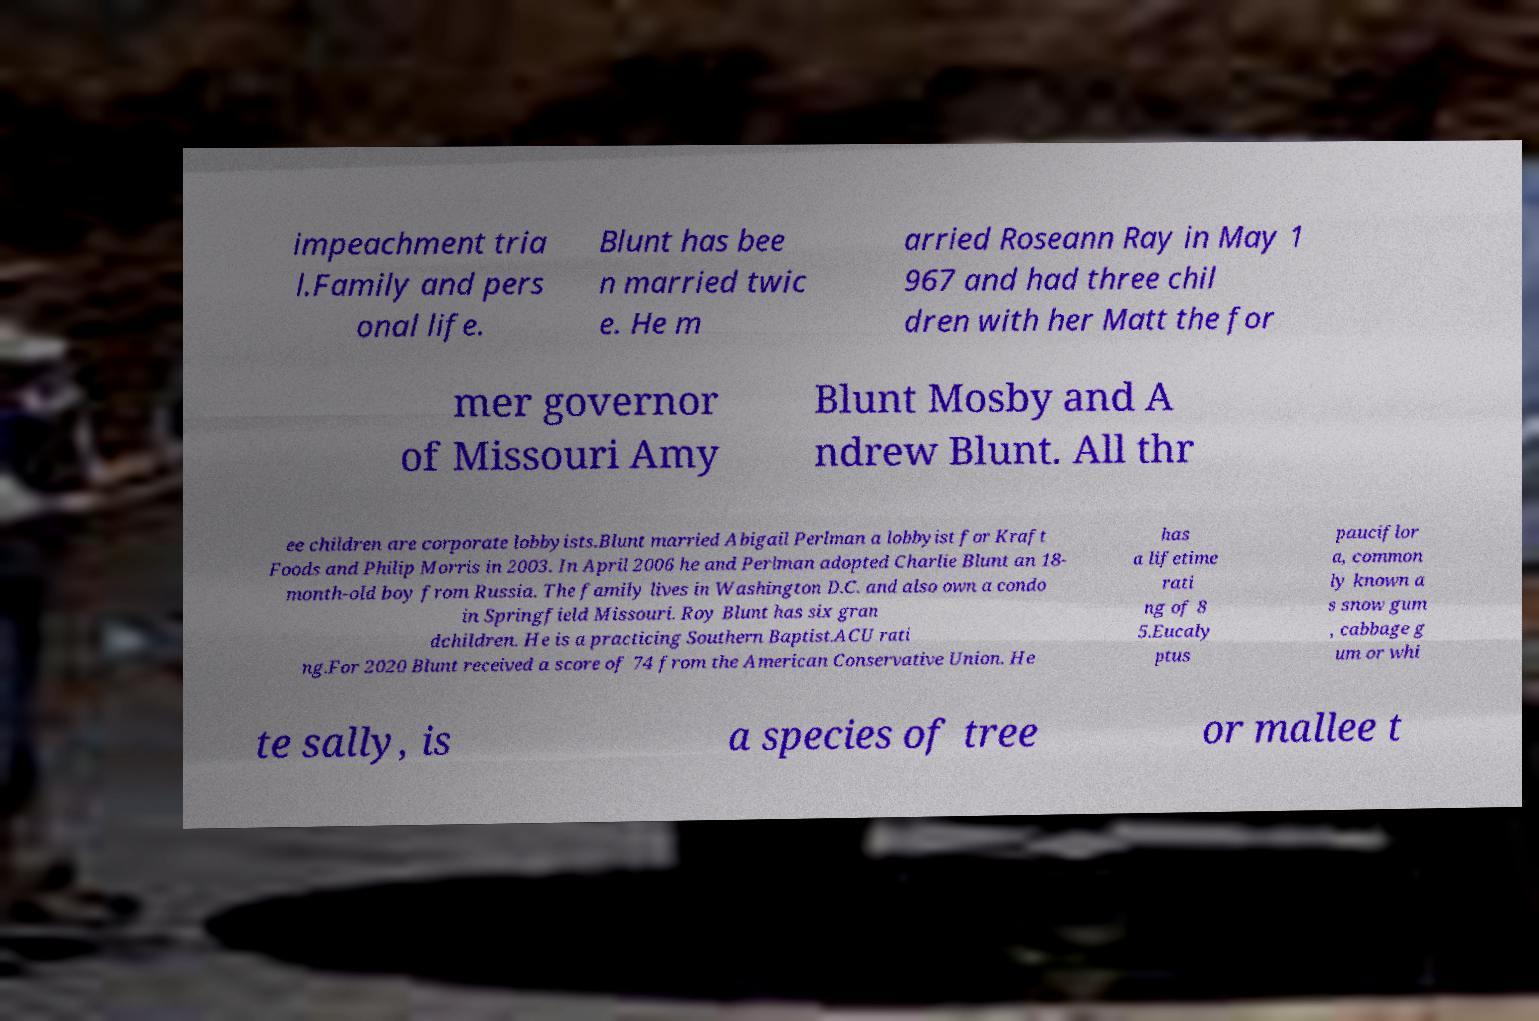Could you assist in decoding the text presented in this image and type it out clearly? impeachment tria l.Family and pers onal life. Blunt has bee n married twic e. He m arried Roseann Ray in May 1 967 and had three chil dren with her Matt the for mer governor of Missouri Amy Blunt Mosby and A ndrew Blunt. All thr ee children are corporate lobbyists.Blunt married Abigail Perlman a lobbyist for Kraft Foods and Philip Morris in 2003. In April 2006 he and Perlman adopted Charlie Blunt an 18- month-old boy from Russia. The family lives in Washington D.C. and also own a condo in Springfield Missouri. Roy Blunt has six gran dchildren. He is a practicing Southern Baptist.ACU rati ng.For 2020 Blunt received a score of 74 from the American Conservative Union. He has a lifetime rati ng of 8 5.Eucaly ptus pauciflor a, common ly known a s snow gum , cabbage g um or whi te sally, is a species of tree or mallee t 